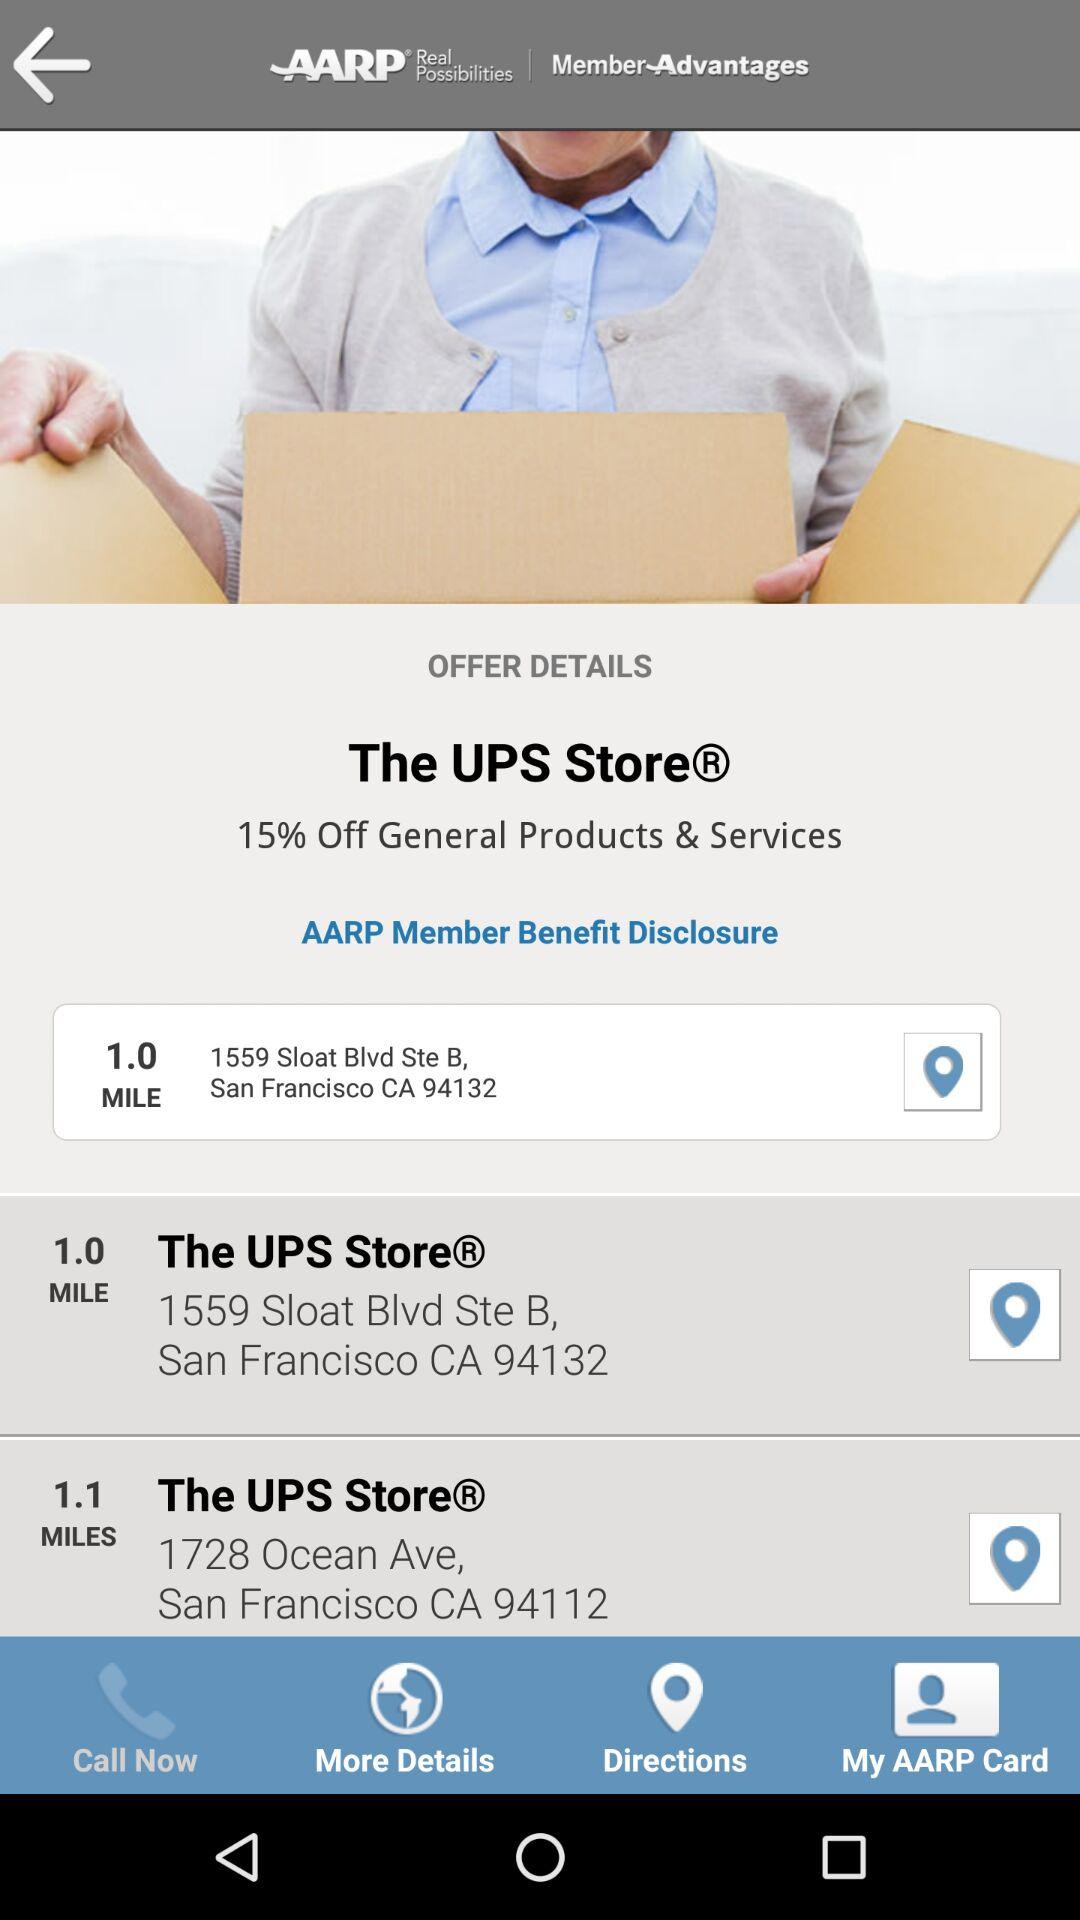What is the discount available at The UPS Store on general products? The discount available is 15%. 